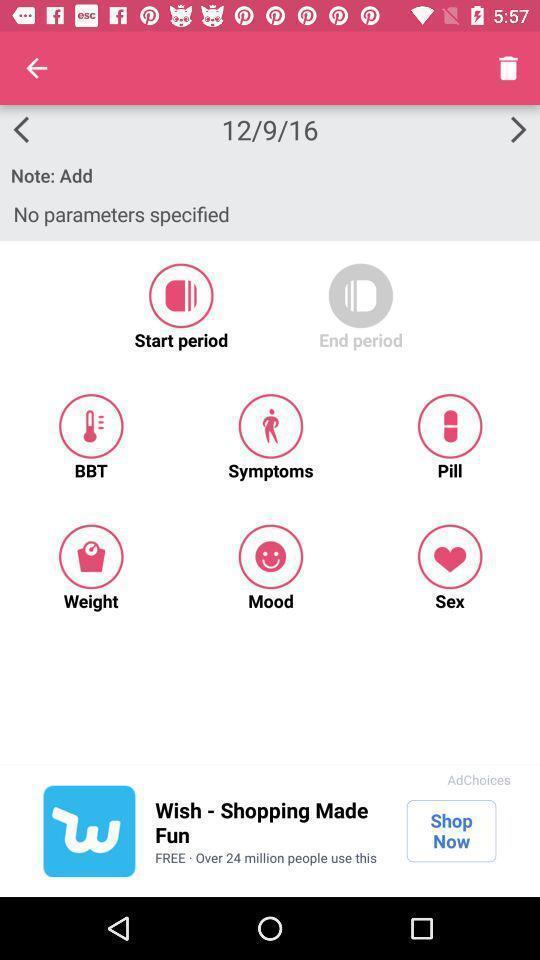Describe the visual elements of this screenshot. Page showing multiple options in a tracker app. 